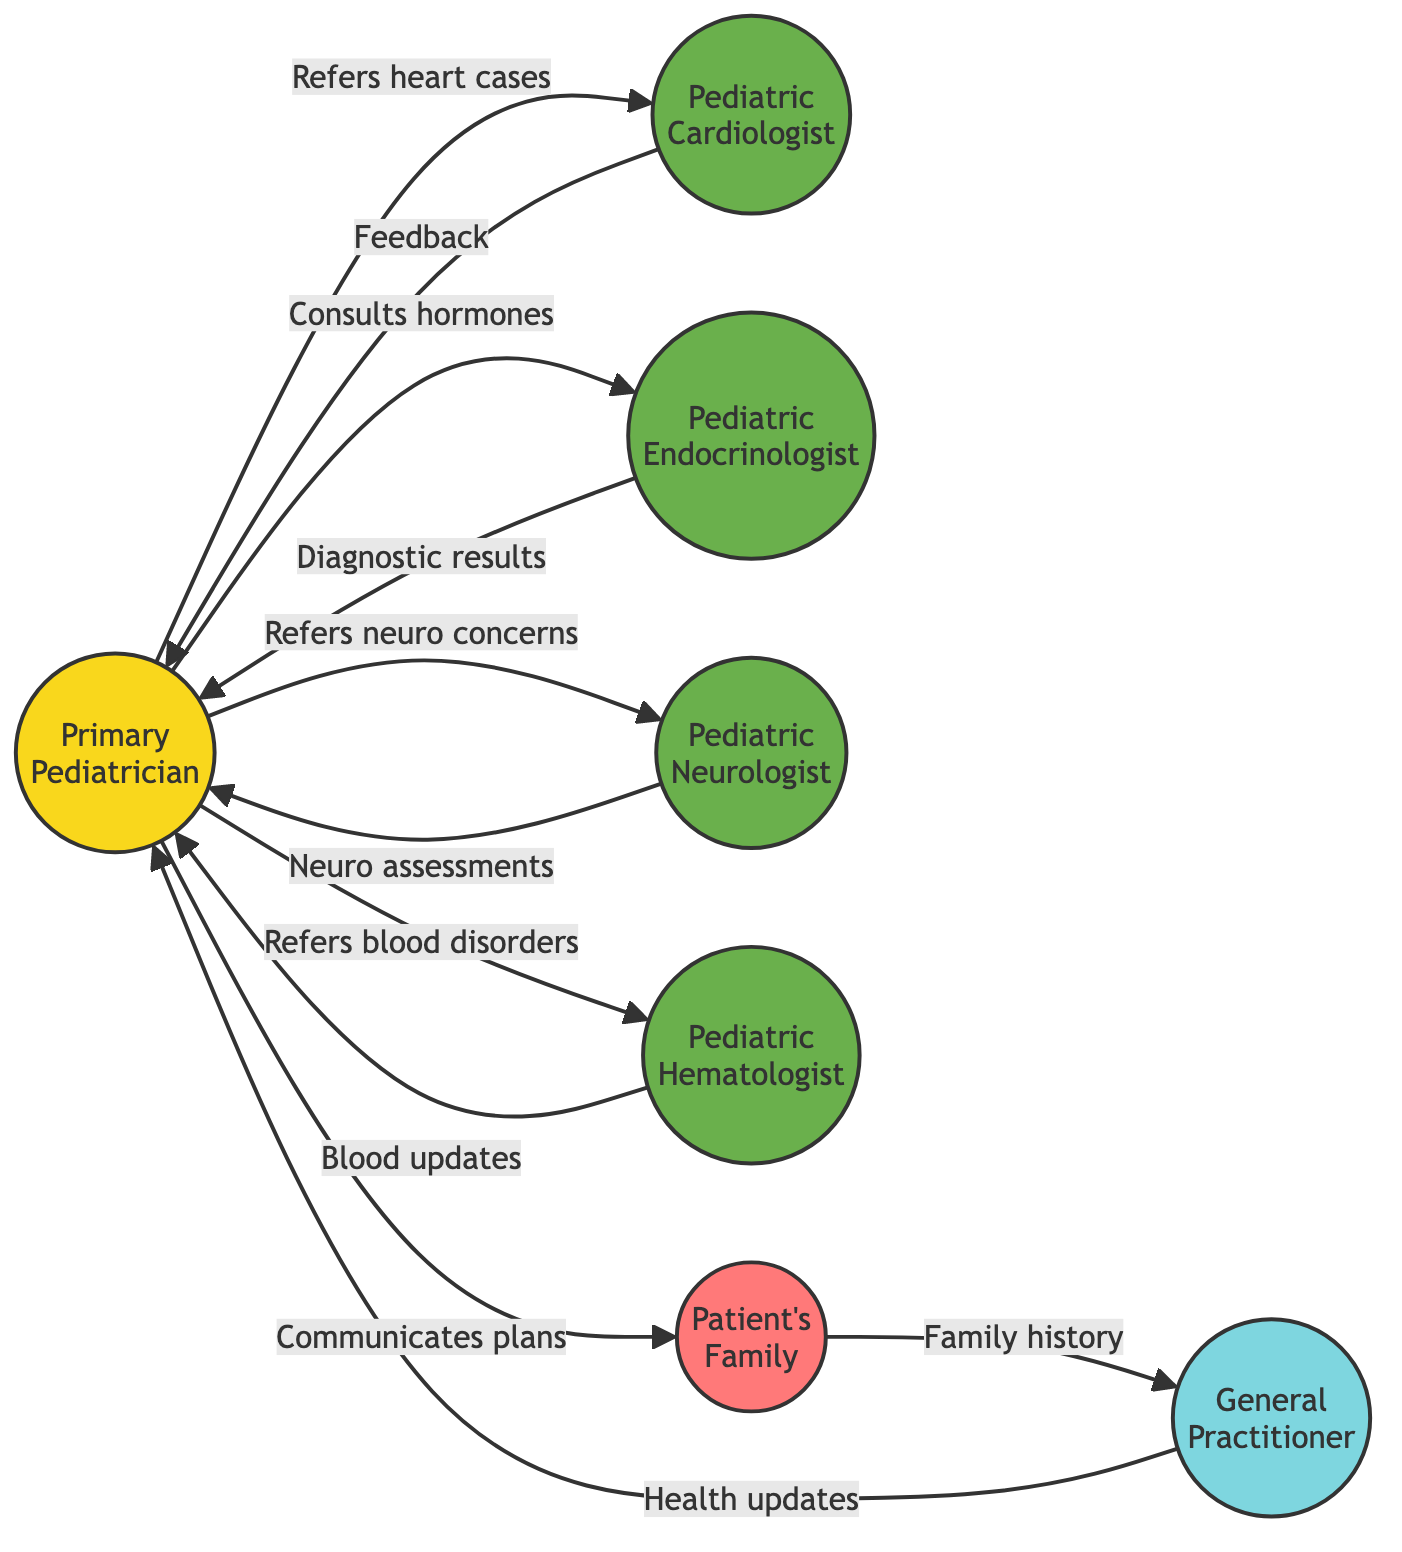What is the initial point of contact in the diagram? The initial point of contact is represented by the node labeled "Primary Pediatrician." This node is explicitly designated as such in the diagram, making it the answer to the question.
Answer: Primary Pediatrician How many pediatric sub-specialists are shown in the diagram? The diagram includes five pediatric sub-specialists: Pediatric Cardiologist, Pediatric Endocrinologist, Pediatric Neurologist, Pediatric Hematologist, and the Primary Pediatrician acts as the first point of contact. Thus, the total is five sub-specialists.
Answer: 5 What role does the Pediatric Hematologist play? The Pediatric Hematologist is identified as a "Blood Specialist" in the diagram, stating its specific area of expertise. Therefore, the role is clear and unambiguous.
Answer: Blood Specialist How many edges connect the Primary Pediatrician to other nodes? Counting the arrows (edges) that originate from the Primary Pediatrician, we find there are five direct connections to other nodes (the specialists and the patient's family), indicating how many interactions it has.
Answer: 5 What type of communication occurs between the Pediatric Cardiologist and the Primary Pediatrician? The communication type is represented by the label "Provides feedback & recommendations," which describes the nature of the interaction from the Cardiologist back to the Primary Pediatrician.
Answer: Provides feedback & recommendations Which node shares family medical history? The node labeled "Patient's Family" is responsible for sharing family medical history, as indicated in the communication flow from this node to the General Practitioner (GP).
Answer: Patient's Family What action does the General Practitioner take in relation to the Primary Pediatrician? The General Practitioner provides "General health updates" to the Primary Pediatrician according to the flow indicated in the diagram, which explains the nature of their interaction.
Answer: Provides general health updates What is the relationship between the Pediatric Endocrinologist and the Primary Pediatrician? The Pediatric Endocrinologist "Reports diagnostic results" to the Primary Pediatrician, establishing a direct communication link to share important medical information.
Answer: Reports diagnostic results How many nodes represent family relationships in the diagram? The Patient's Family is the only node representing family relationships, so there is just one node that signifies the family's role in the communication flow.
Answer: 1 